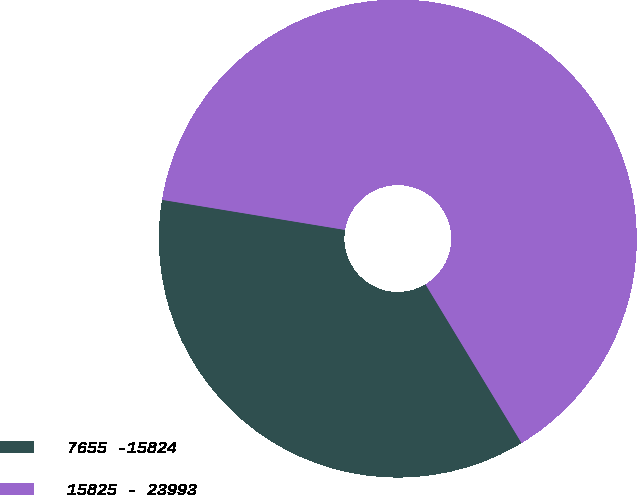<chart> <loc_0><loc_0><loc_500><loc_500><pie_chart><fcel>7655 -15824<fcel>15825 - 23993<nl><fcel>36.26%<fcel>63.74%<nl></chart> 